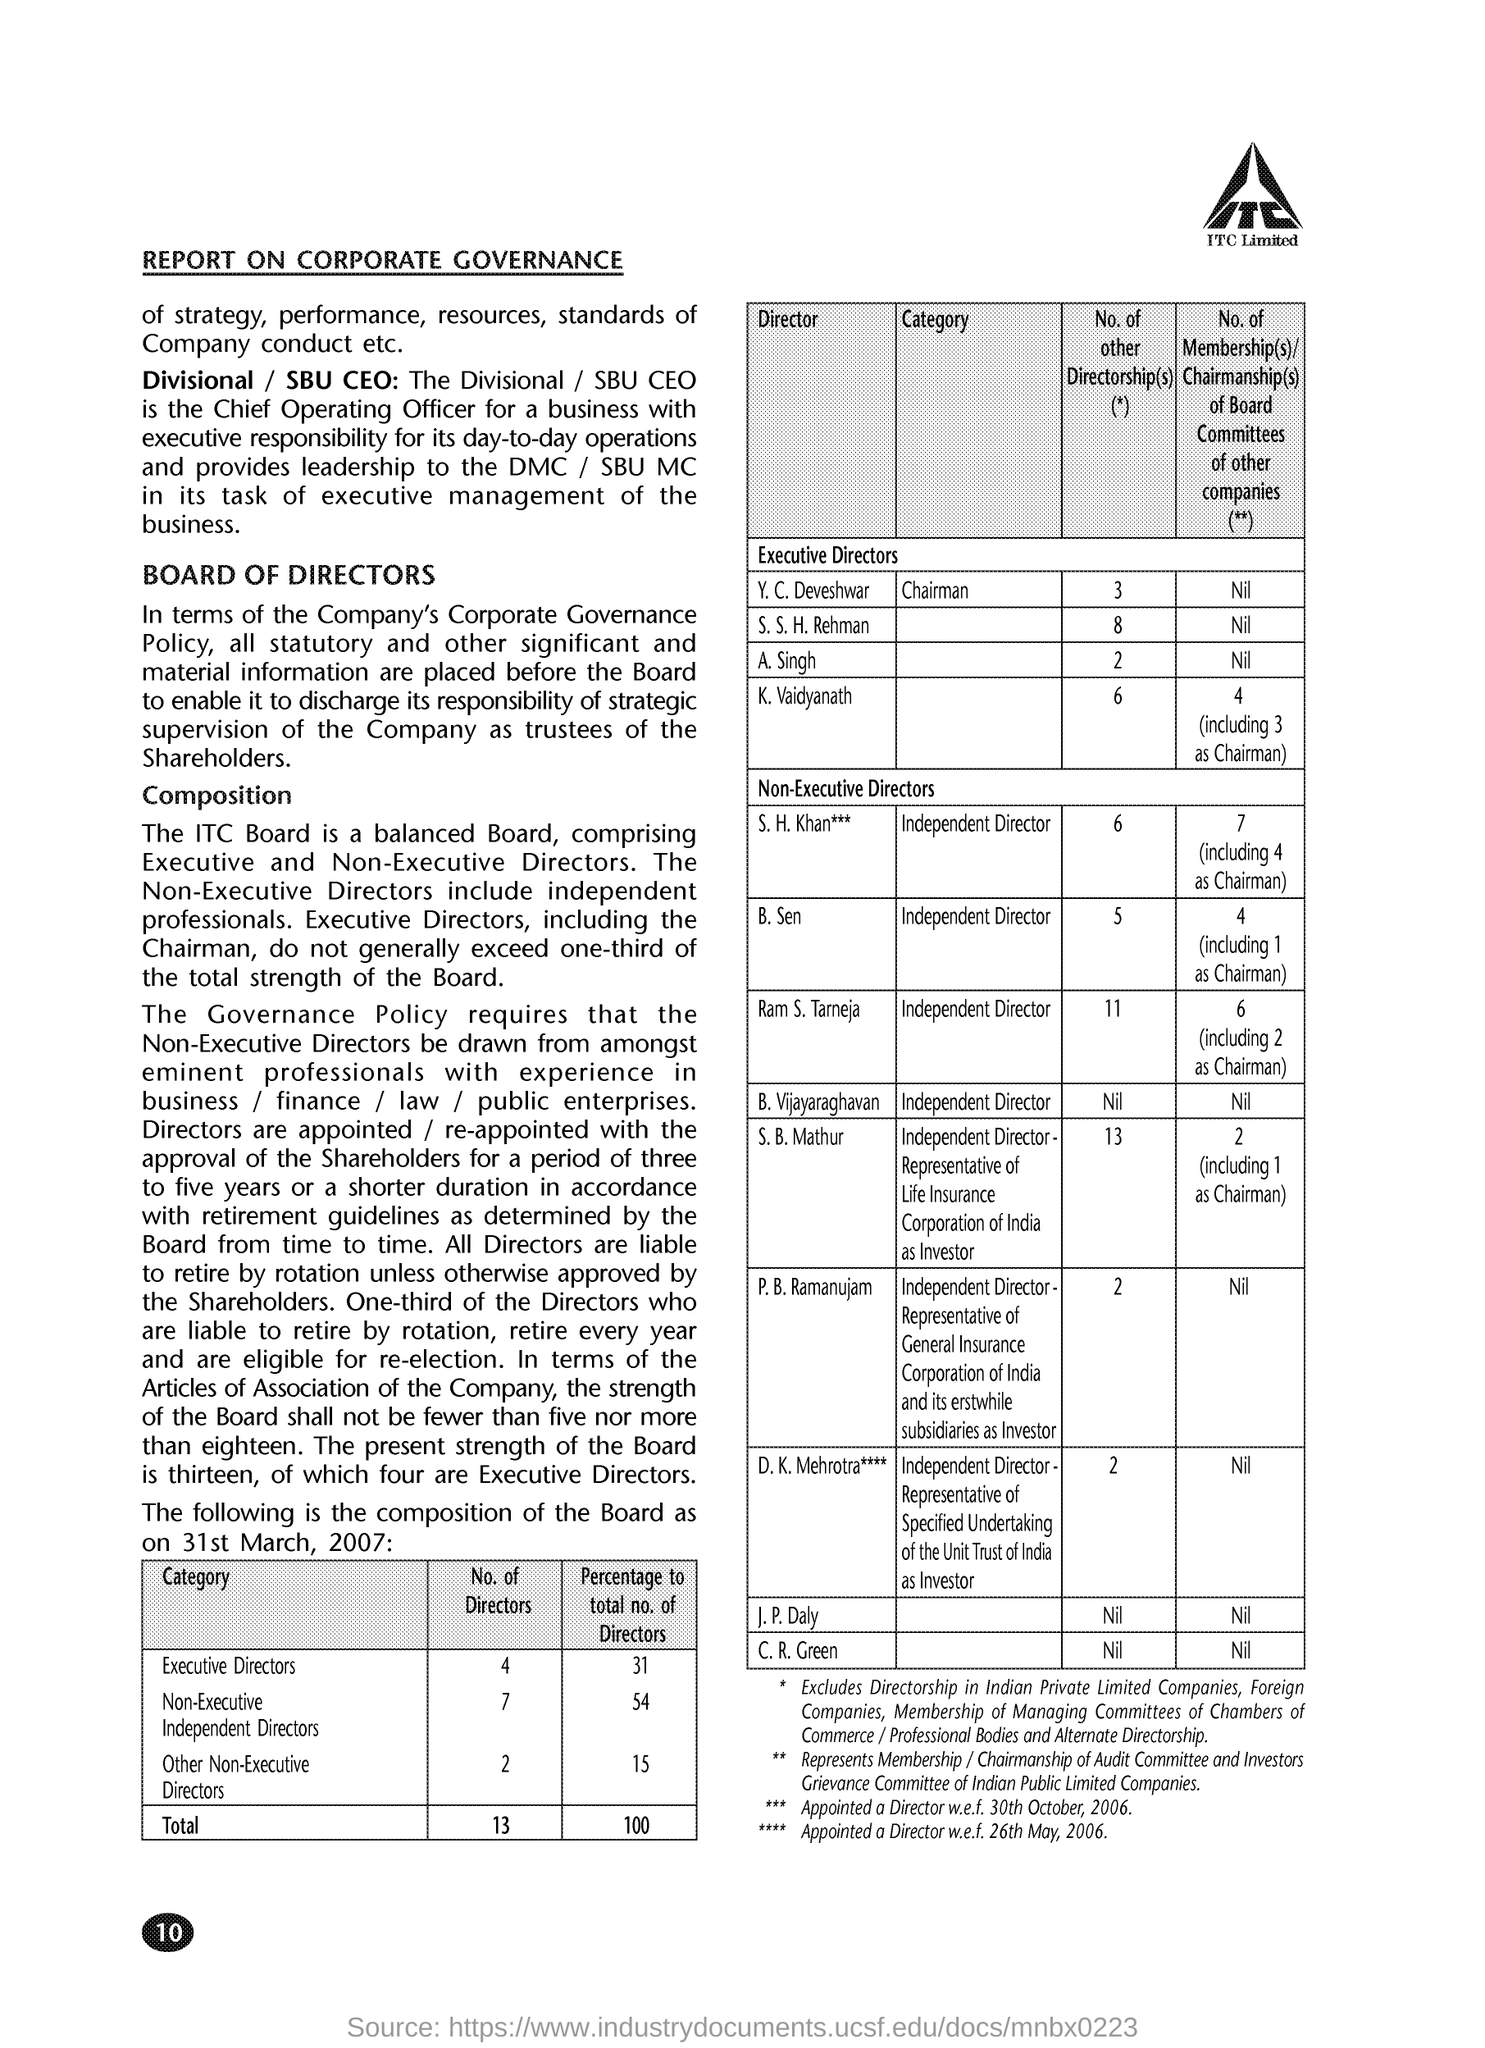Indicate a few pertinent items in this graphic. The date on the document is March 31, 2007, as indicated by the written text "31st March, 2007. There are four Executive Directors. There are 7 non-executive independent directors. There are two other non-executive directors. There are a total of 13 directors. 